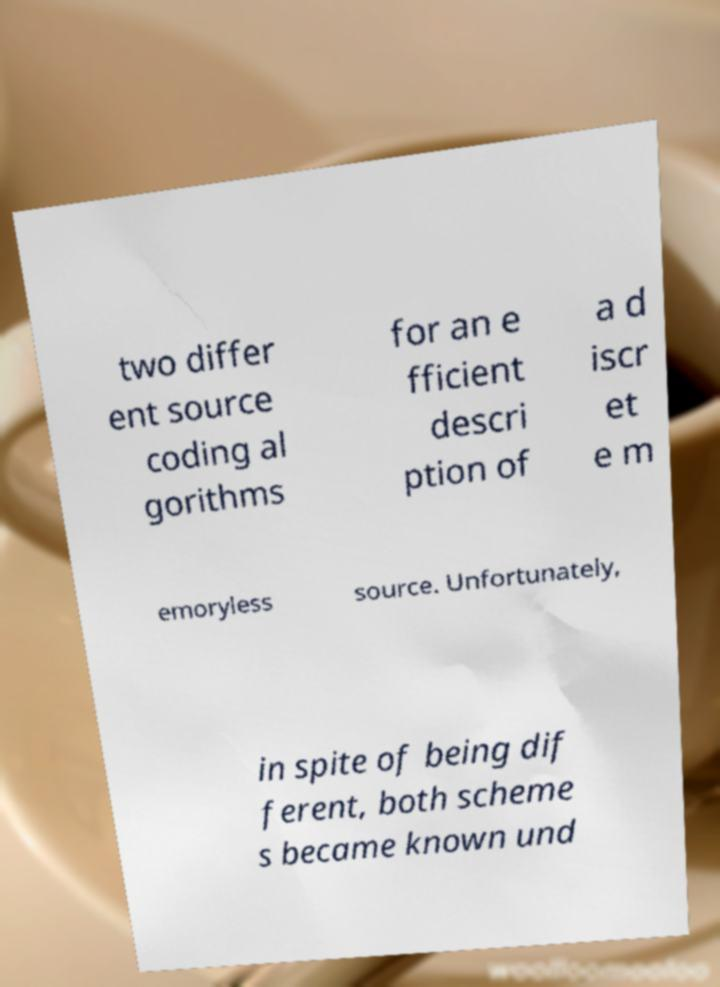Please read and relay the text visible in this image. What does it say? two differ ent source coding al gorithms for an e fficient descri ption of a d iscr et e m emoryless source. Unfortunately, in spite of being dif ferent, both scheme s became known und 